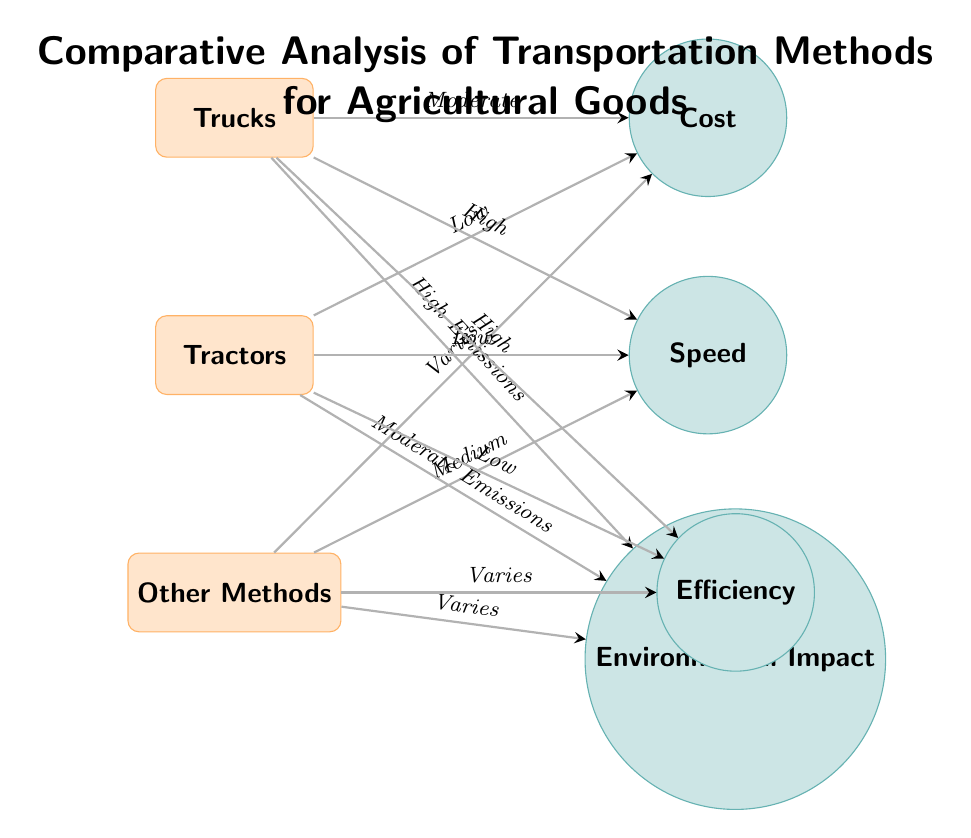What is the cost status for Trucks? The diagram shows an edge connecting the 'Trucks' node to the 'Cost' factor node with the label "Moderate." This indicates the cost associated with using trucks for transportation.
Answer: Moderate What are the emissions associated with Tractors? The diagram indicates that the edge from 'Tractors' to 'Environmental Impact' is labeled "Moderate Emissions." This defines the environmental impact in terms of emissions when using tractors.
Answer: Moderate Emissions Which transport method has the highest speed? The speed values linked to each transport method show that 'Trucks' connect to 'Speed' with "High," indicating it is the fastest method of transportation among those listed.
Answer: High How do the emissions of 'Other Methods' compare to trucks? The diagram shows that 'Other Methods' are connected to 'Environmental Impact' through "Varies" while trucks are labeled "High Emissions." Since "Varies" suggests uncertainty, this directly indicates that other methods have different emissions levels compared to trucks.
Answer: Varied Which transportation method is characterized by low efficiency? The diagram indicates that 'Tractors' have an edge connecting to 'Efficiency' that states "Low." This means that tractors are the least efficient in transporting agricultural goods among the methods listed.
Answer: Low Explain the relationship between cost and speed for Tractors. The table shows that 'Tractors' are linked to both 'Cost' with "Low" and 'Speed' with "Low." This means that while tractors are cheaper, they also provide a slower mode of transport, showcasing a trade-off between the two factors.
Answer: Low cost and low speed Which transport method has a variable environmental impact? The node 'Environmental Impact' highlights 'Other Methods' which connects through "Varies." This signifies that the environmental consequences of these methods are inconsistent and can differ widely, unlike trucks and tractors that have defined emissions.
Answer: Other Methods Summarize the cost efficiency of using Trucks compared to Tractors. The diagram points out that 'Trucks' are "Moderate" in cost and "High" in efficiency, whereas 'Tractors' are "Low" in cost but "Low" in efficiency, suggesting that trucks are more cost-efficient for their benefits despite a higher expense.
Answer: More cost-efficient What does the layout of the nodes suggest about Transportation Methods? The diagram's flow, showing the transportation methods aligned vertically with factors horizontally, conveys a clear comparison of their respective advantages and disadvantages across multiple categories, aiding in decision-making for agricultural transport.
Answer: Comparative alignment of methods and factors 